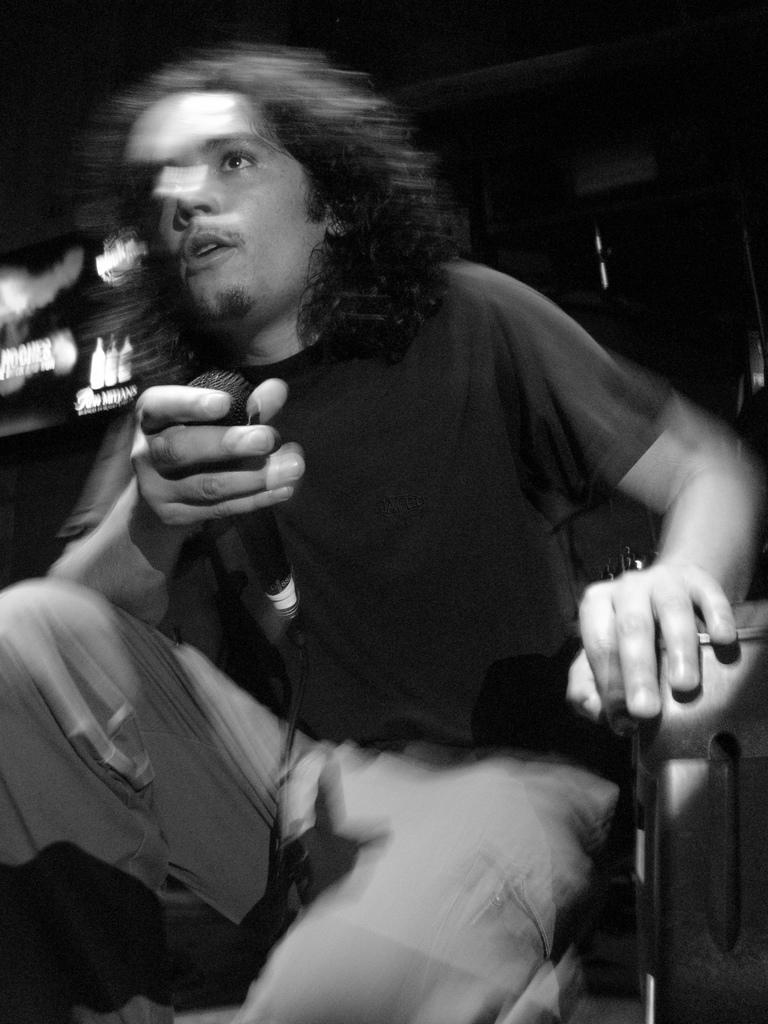What is the main subject of the image? There is a person in the image. What is the person doing in the image? The person is sitting on a chair and holding a microphone. Can you describe the background of the image? The background of the image is blurred. What type of yarn is the person using to knit in the image? There is no yarn or knitting activity present in the image. Can you see any visible wrist injuries on the person in the image? There is no indication of any wrist injuries or medical conditions on the person in the image. 